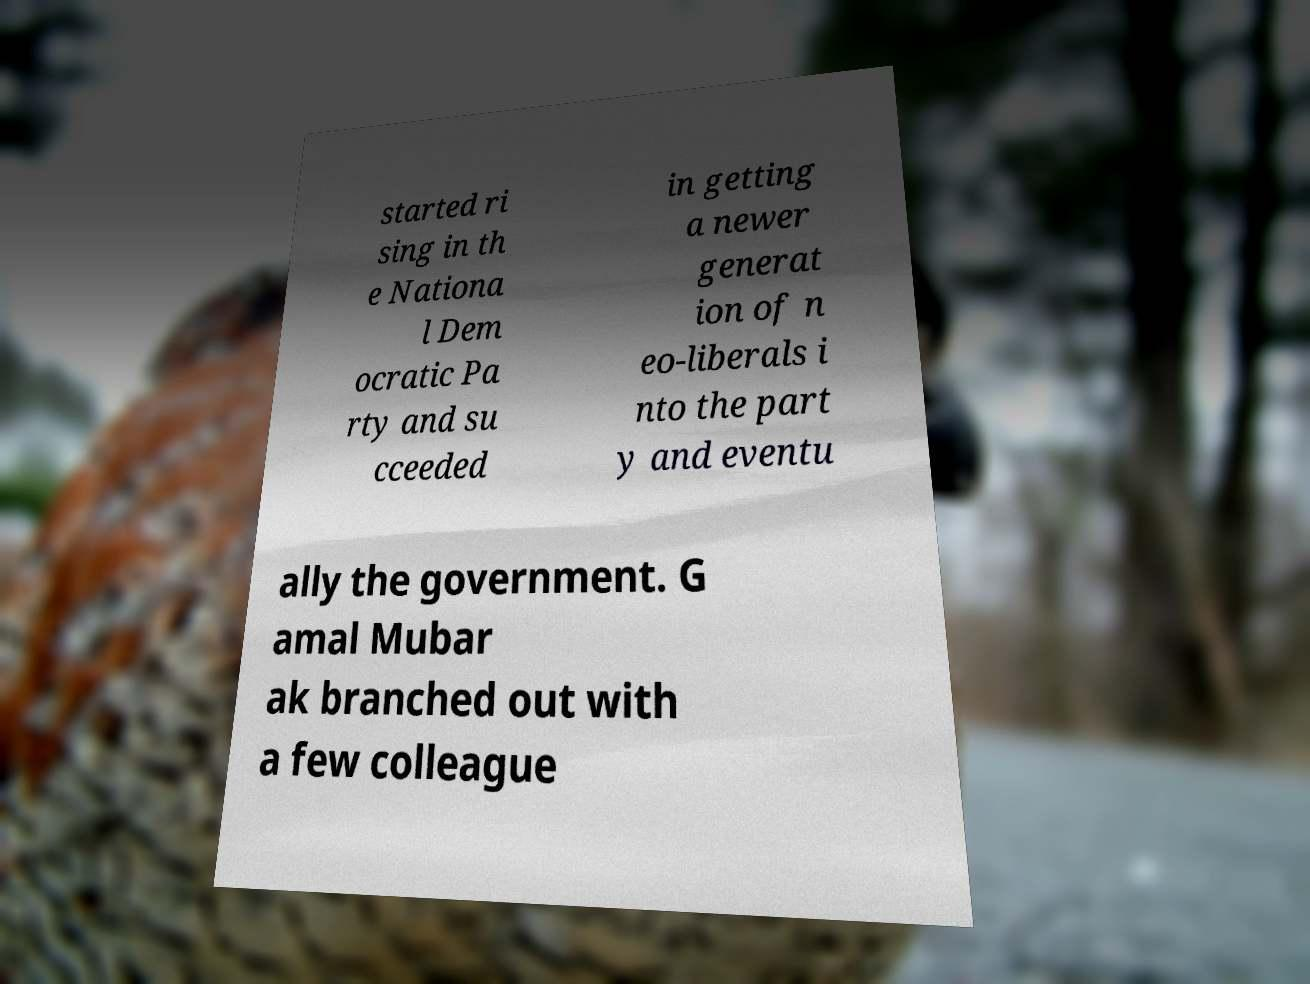Could you extract and type out the text from this image? started ri sing in th e Nationa l Dem ocratic Pa rty and su cceeded in getting a newer generat ion of n eo-liberals i nto the part y and eventu ally the government. G amal Mubar ak branched out with a few colleague 